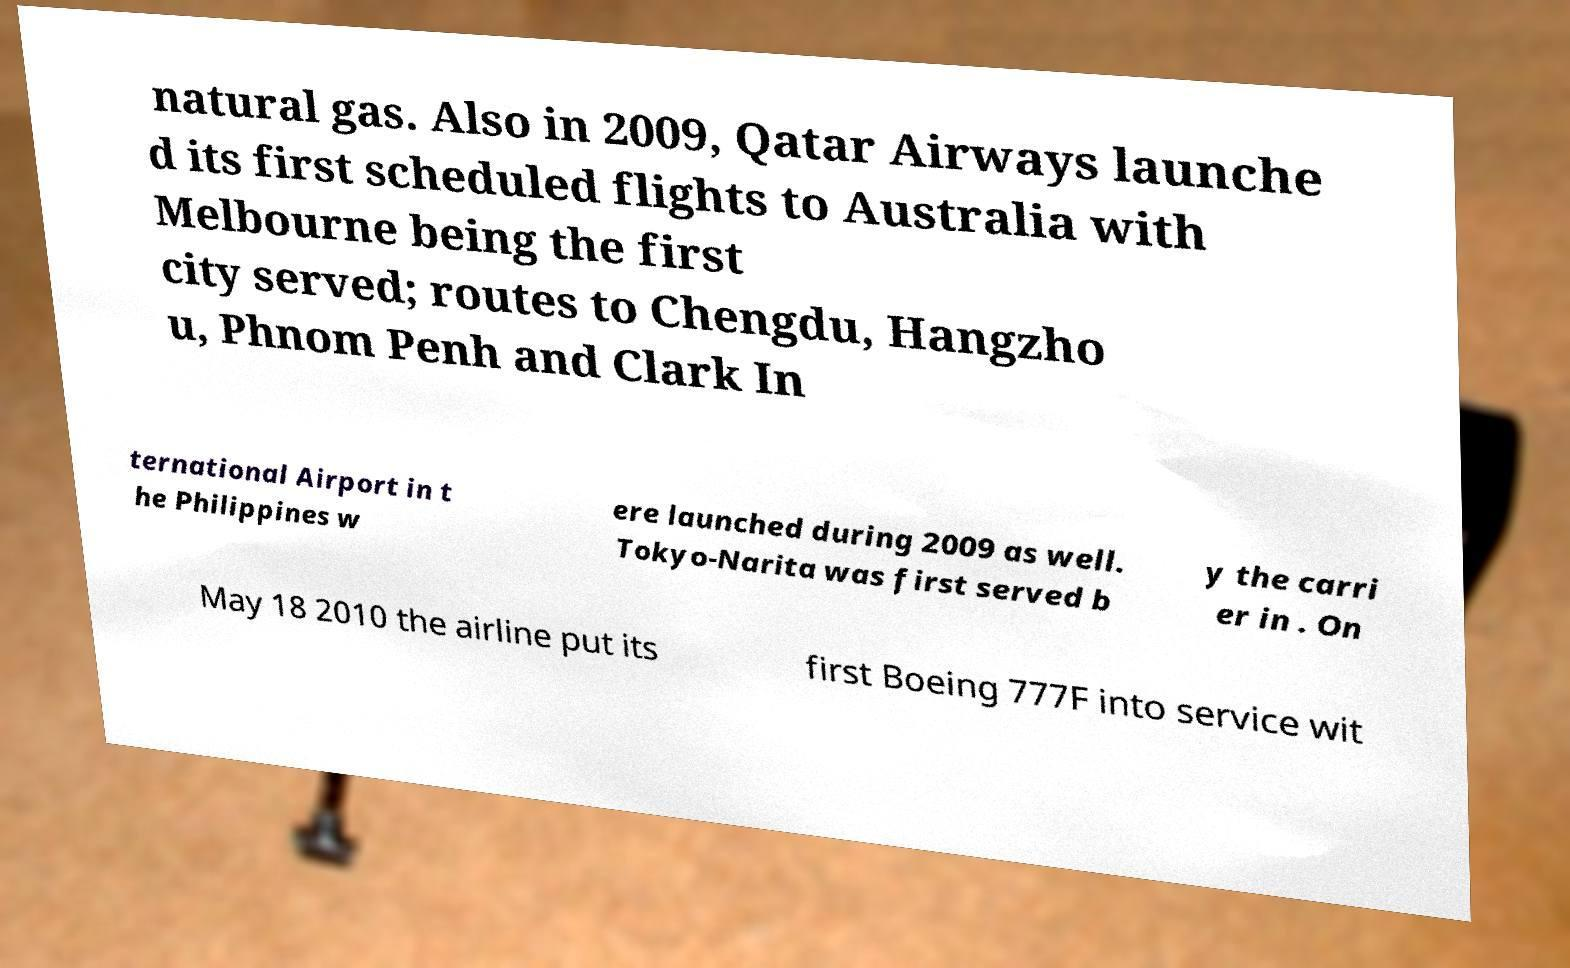Can you read and provide the text displayed in the image?This photo seems to have some interesting text. Can you extract and type it out for me? natural gas. Also in 2009, Qatar Airways launche d its first scheduled flights to Australia with Melbourne being the first city served; routes to Chengdu, Hangzho u, Phnom Penh and Clark In ternational Airport in t he Philippines w ere launched during 2009 as well. Tokyo-Narita was first served b y the carri er in . On May 18 2010 the airline put its first Boeing 777F into service wit 